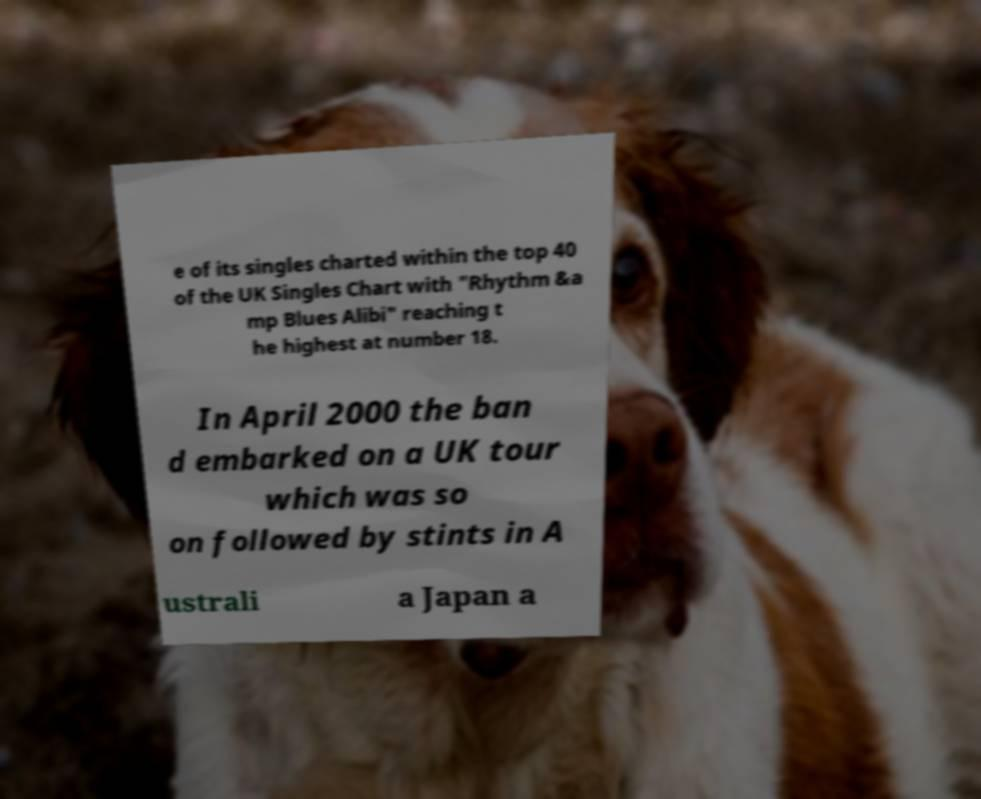What messages or text are displayed in this image? I need them in a readable, typed format. e of its singles charted within the top 40 of the UK Singles Chart with "Rhythm &a mp Blues Alibi" reaching t he highest at number 18. In April 2000 the ban d embarked on a UK tour which was so on followed by stints in A ustrali a Japan a 